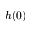<formula> <loc_0><loc_0><loc_500><loc_500>h ( 0 )</formula> 